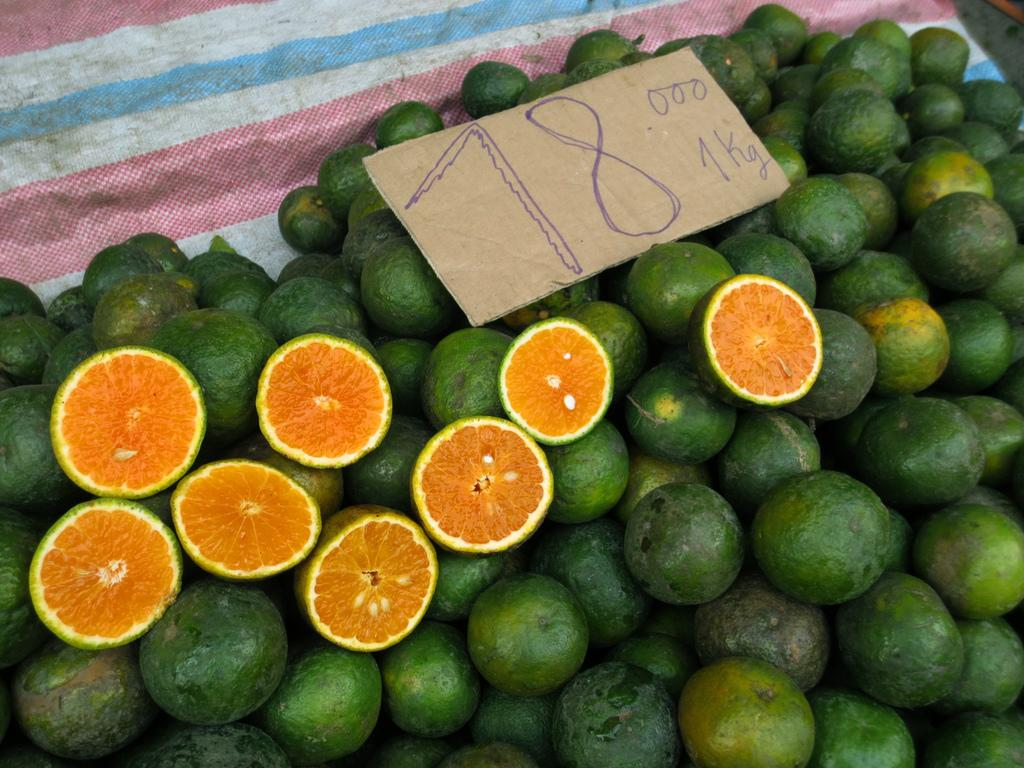What is in the foreground of the image? There are oranges in the foreground of the image. How are the oranges presented in the image? There are cut pieces of oranges in the image. What is the surface on which the oranges and cut pieces are placed? The oranges and cut pieces are on a cloth. Is there any information about the price of the oranges in the image? Yes, there is a price board in the image. What type of underwear is visible under the cloth in the image? There is no underwear visible in the image; it only features oranges, cut pieces, and a cloth. 